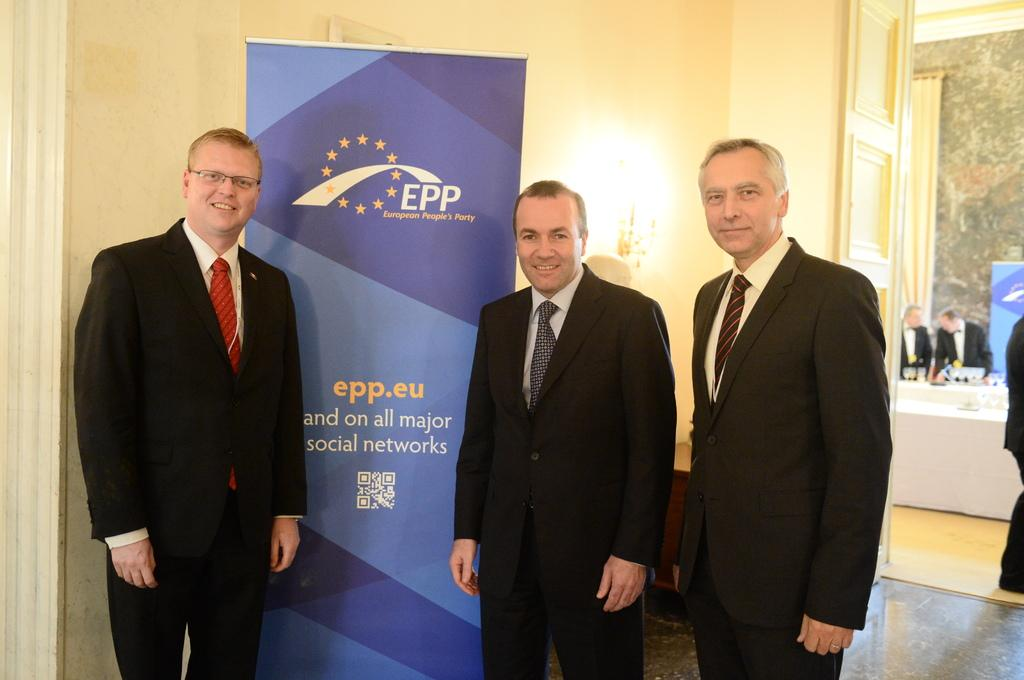How many people are in the image? There is a group of people standing in the image. Where are the people standing? The people are standing on the floor. What can be seen in the background of the image? There is a door, a curtain, a lamp, and a poster with text in the background of the image. What type of spark can be seen coming from the chin of the person in the image? There is no spark or any indication of a spark in the image. 